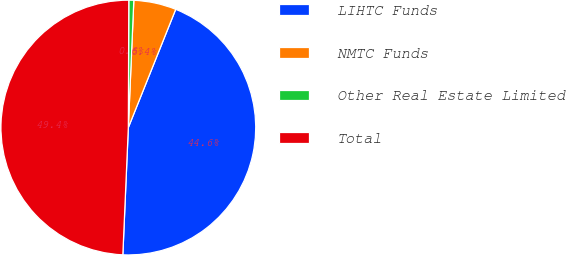Convert chart. <chart><loc_0><loc_0><loc_500><loc_500><pie_chart><fcel>LIHTC Funds<fcel>NMTC Funds<fcel>Other Real Estate Limited<fcel>Total<nl><fcel>44.62%<fcel>5.38%<fcel>0.63%<fcel>49.37%<nl></chart> 